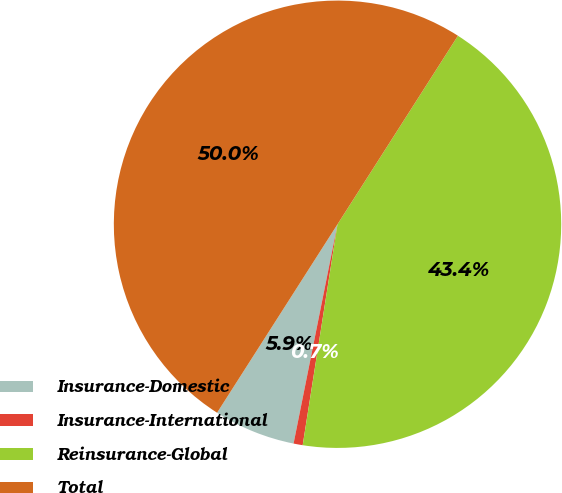Convert chart to OTSL. <chart><loc_0><loc_0><loc_500><loc_500><pie_chart><fcel>Insurance-Domestic<fcel>Insurance-International<fcel>Reinsurance-Global<fcel>Total<nl><fcel>5.9%<fcel>0.66%<fcel>43.44%<fcel>50.0%<nl></chart> 